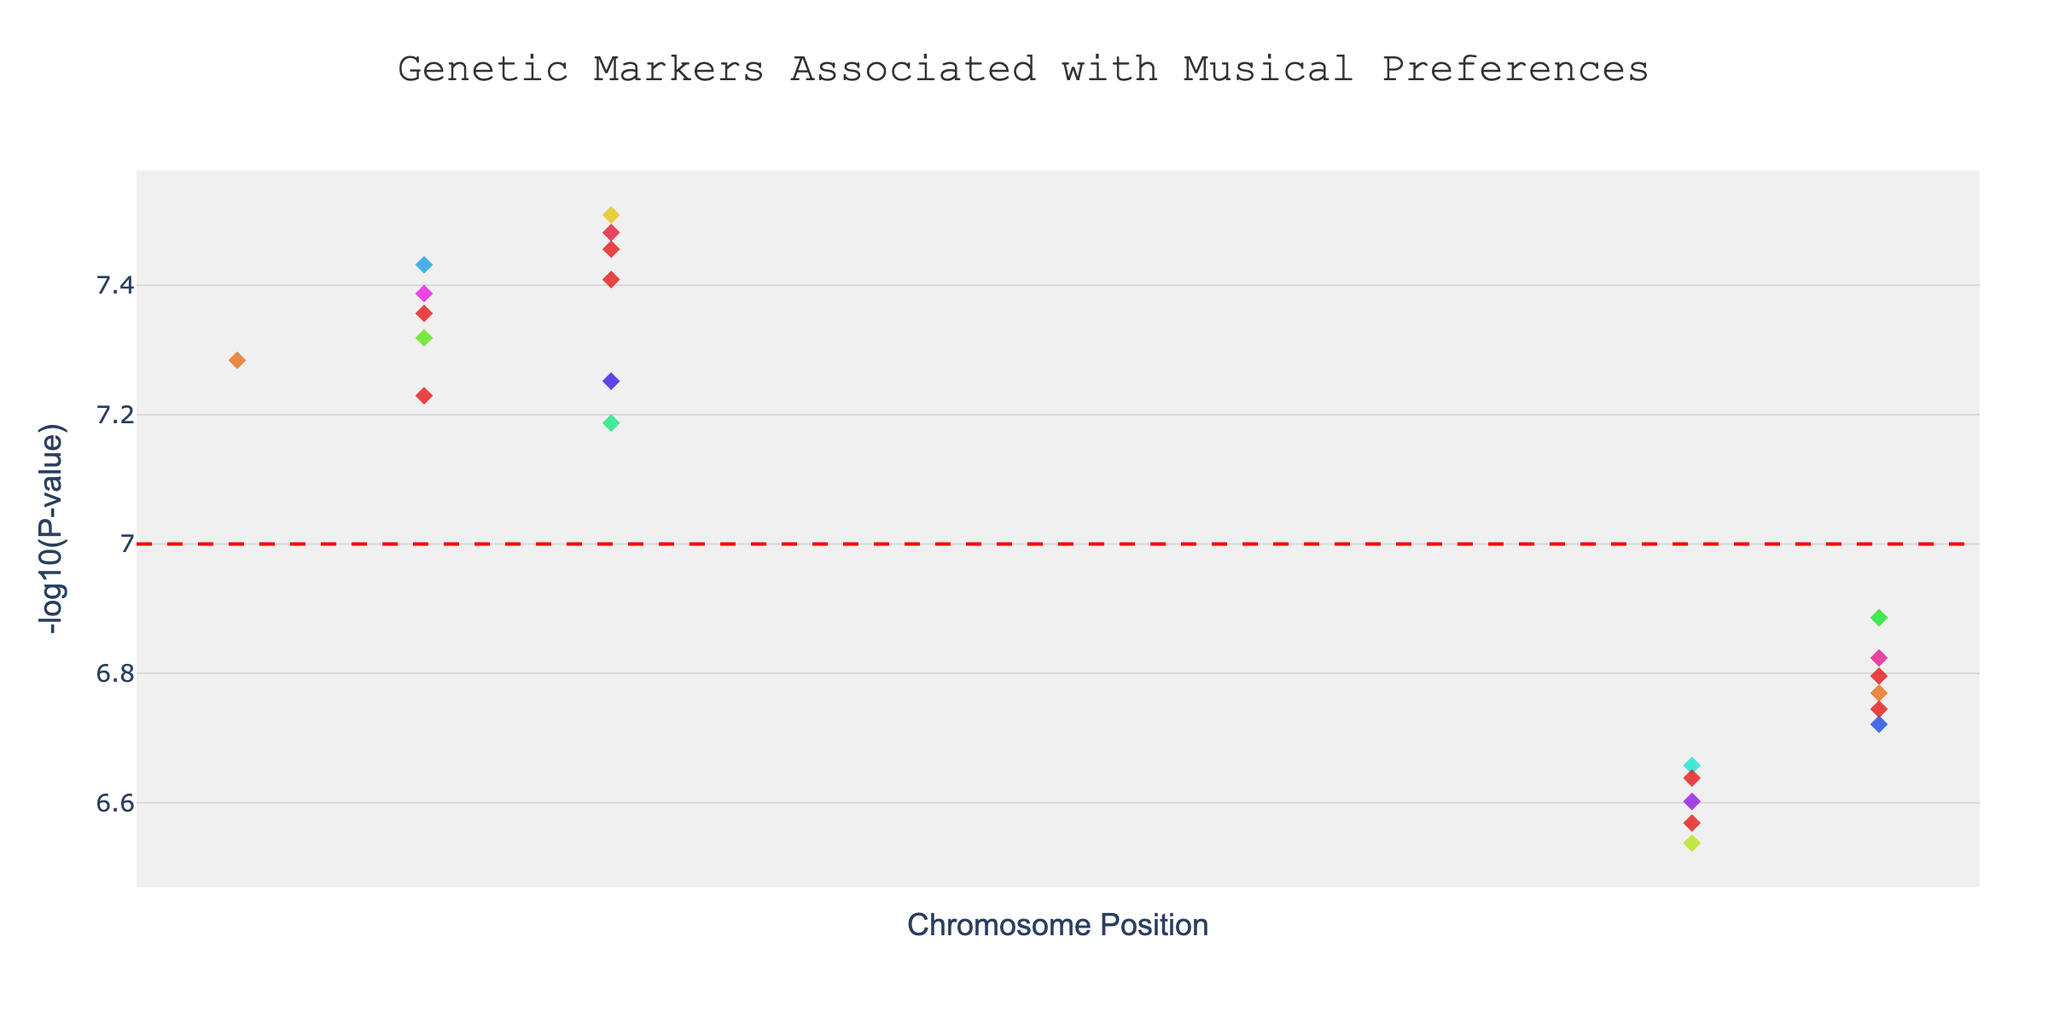What is the title of the plot? The plot title is usually displayed prominently at the top of the figure, summarizing what the figure is about. In this case, it reads "Genetic Markers Associated with Musical Preferences."
Answer: Genetic Markers Associated with Musical Preferences What does the y-axis represent? By observing the y-axis label, you can see it is labeled as "-log10(P-value)," which informs us that the y-axis represents the negative logarithm of the p-values.
Answer: -log10(P-value) Which chromosome has the genetic marker with the lowest p-value? To determine this, look for the highest point on the y-axis, which corresponds to the lowest p-value. The genetic marker with the highest y-axis value is on Chromosome 1.
Answer: Chromosome 1 How many chromosomes have data points shown in the plot? Count the unique chromosome labels on the x-axis or in the legend. There are 22 chromosomes represented in the plot.
Answer: 22 What color is used to represent Chromosome 7? Observe the legend or the points plotted for Chromosome 7. It is typically assigned a unique color; in this figure, Chromosome 7 uses a light green hue.
Answer: light green Which chromosome has the most significant genetic marker for auditory processing? Find the label for auditory processing in the hover information or the labels. The marker falls on Chromosome 14.
Answer: Chromosome 14 Is there a significance line indicated in the plot, and what is its value? A significance line is evident as a horizontal dashed red line. It is placed at y = 7, corresponding to the significance threshold (p-value ≈ 5e-8).
Answer: Yes, y = 7 Which trait is associated with the SNP rs53576? Find the SNP rs53576 in the x-axis labels or hover information. It maps to the trait "Emotional impact of album artwork", shown at the position marker for Chromosome 12.
Answer: Emotional impact of album artwork Which trait has the lowest -log10(P-value) and what is its corresponding SNP? Locate the lowest point on the y-axis. From the chart, the lowest -log10(P-value) corresponds to Jazz preference on Chromosome 7 with SNP rs17782313.
Answer: Jazz preference, rs17782313 What is the average -log10(P-value) for SNPs on Chromosome 3? Calculate the average of the y-axis values for points on Chromosome 3. For Chromosome 3, there is one data point with a -log10(P-value) of approximately 6.54. So, it's simply the same value.
Answer: 6.54 